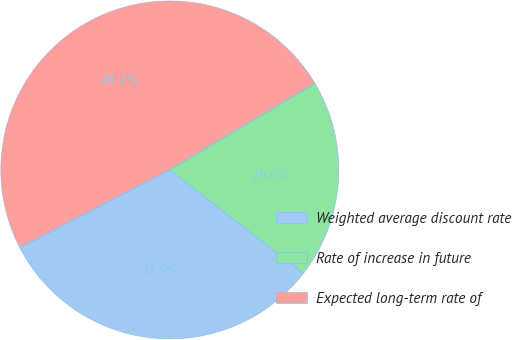Convert chart to OTSL. <chart><loc_0><loc_0><loc_500><loc_500><pie_chart><fcel>Weighted average discount rate<fcel>Rate of increase in future<fcel>Expected long-term rate of<nl><fcel>31.89%<fcel>19.01%<fcel>49.09%<nl></chart> 